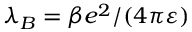<formula> <loc_0><loc_0><loc_500><loc_500>\lambda _ { B } = \beta e ^ { 2 } / ( 4 \pi \varepsilon )</formula> 